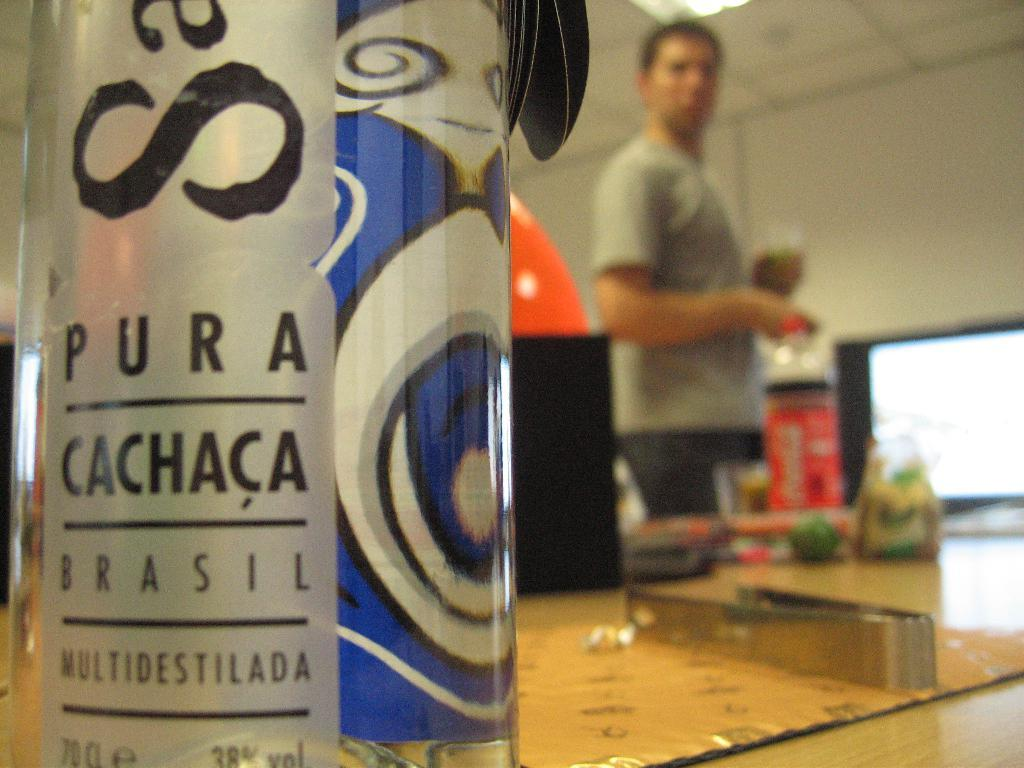<image>
Render a clear and concise summary of the photo. A box of Cachaca alcohol is one of several items on a table. 